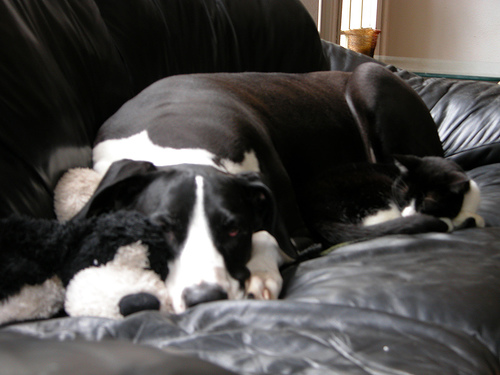Can you describe the relationship between the animals in this picture? While we cannot assert their relationship concretely, the proximity and relaxed postures of the dog and cat imply a harmonious relationship, suggesting that they are comfortable and possibly fond of each other's company. 